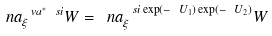Convert formula to latex. <formula><loc_0><loc_0><loc_500><loc_500>\ n a ^ { \ v a ^ { * } \ s i } _ { \xi } W = \ n a ^ { \ s i \exp ( - \ U _ { 1 } ) \exp ( - \ U _ { 2 } ) } _ { \xi } W</formula> 